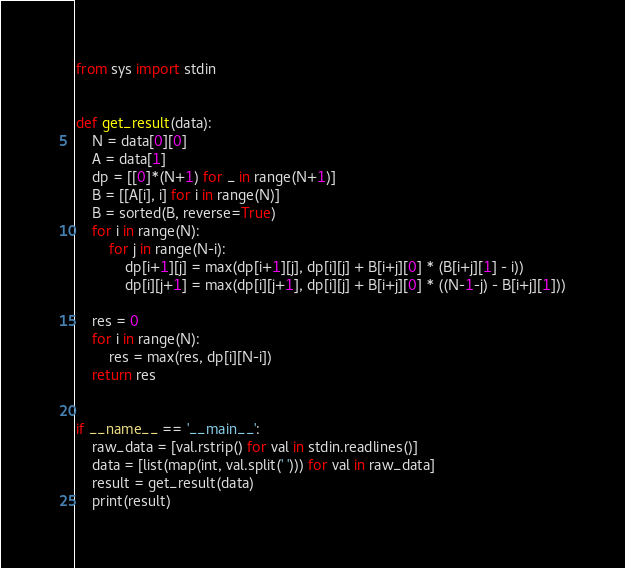<code> <loc_0><loc_0><loc_500><loc_500><_Python_>from sys import stdin


def get_result(data):
    N = data[0][0]
    A = data[1]
    dp = [[0]*(N+1) for _ in range(N+1)]
    B = [[A[i], i] for i in range(N)]
    B = sorted(B, reverse=True)
    for i in range(N):
        for j in range(N-i):
            dp[i+1][j] = max(dp[i+1][j], dp[i][j] + B[i+j][0] * (B[i+j][1] - i))
            dp[i][j+1] = max(dp[i][j+1], dp[i][j] + B[i+j][0] * ((N-1-j) - B[i+j][1]))

    res = 0
    for i in range(N):
        res = max(res, dp[i][N-i])
    return res


if __name__ == '__main__':
    raw_data = [val.rstrip() for val in stdin.readlines()]
    data = [list(map(int, val.split(' '))) for val in raw_data]
    result = get_result(data)
    print(result)
</code> 